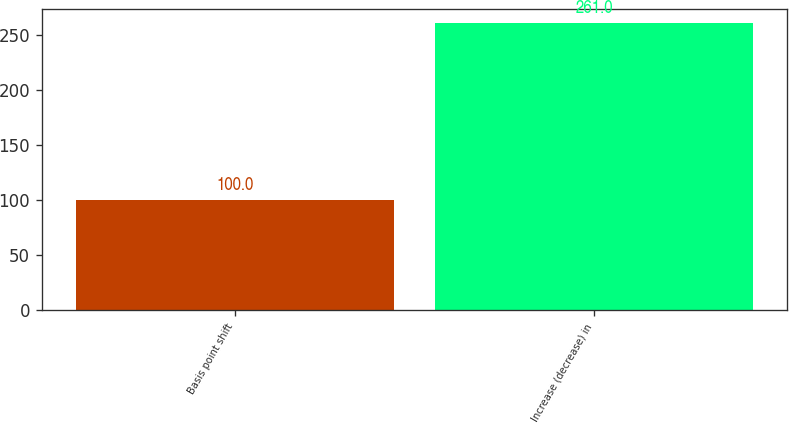<chart> <loc_0><loc_0><loc_500><loc_500><bar_chart><fcel>Basis point shift<fcel>Increase (decrease) in<nl><fcel>100<fcel>261<nl></chart> 